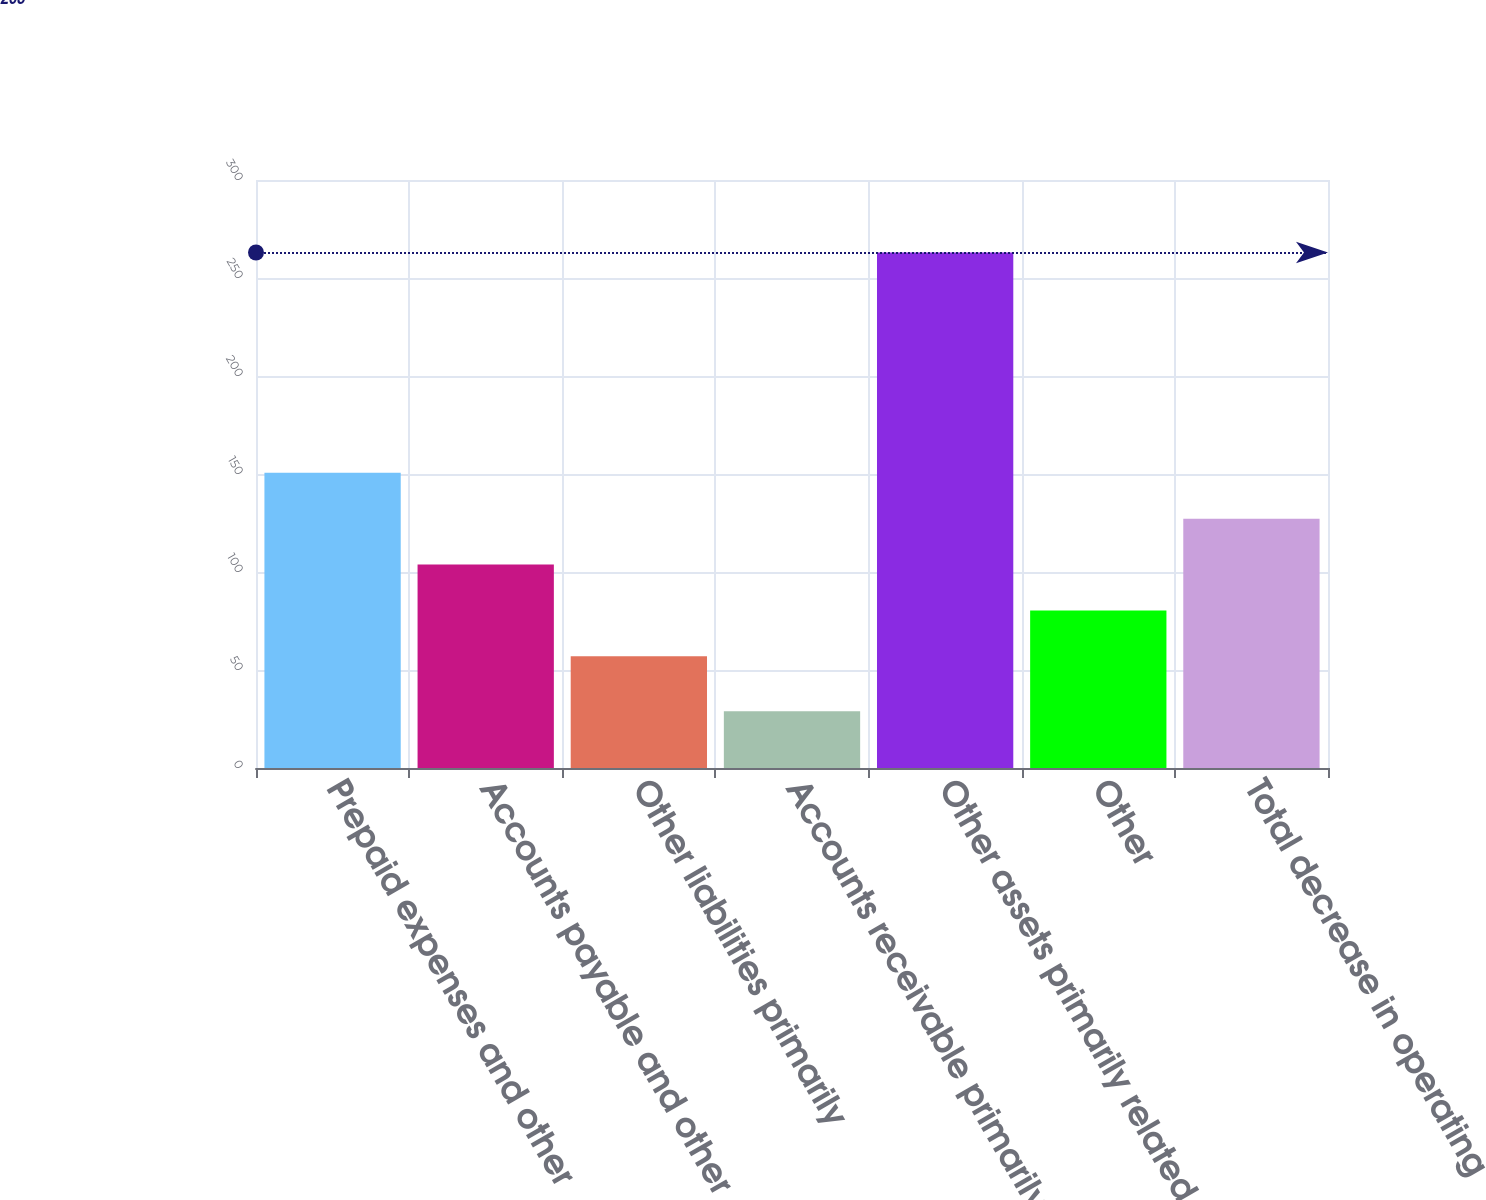<chart> <loc_0><loc_0><loc_500><loc_500><bar_chart><fcel>Prepaid expenses and other<fcel>Accounts payable and other<fcel>Other liabilities primarily<fcel>Accounts receivable primarily<fcel>Other assets primarily related<fcel>Other<fcel>Total decrease in operating<nl><fcel>150.6<fcel>103.8<fcel>57<fcel>29<fcel>263<fcel>80.4<fcel>127.2<nl></chart> 